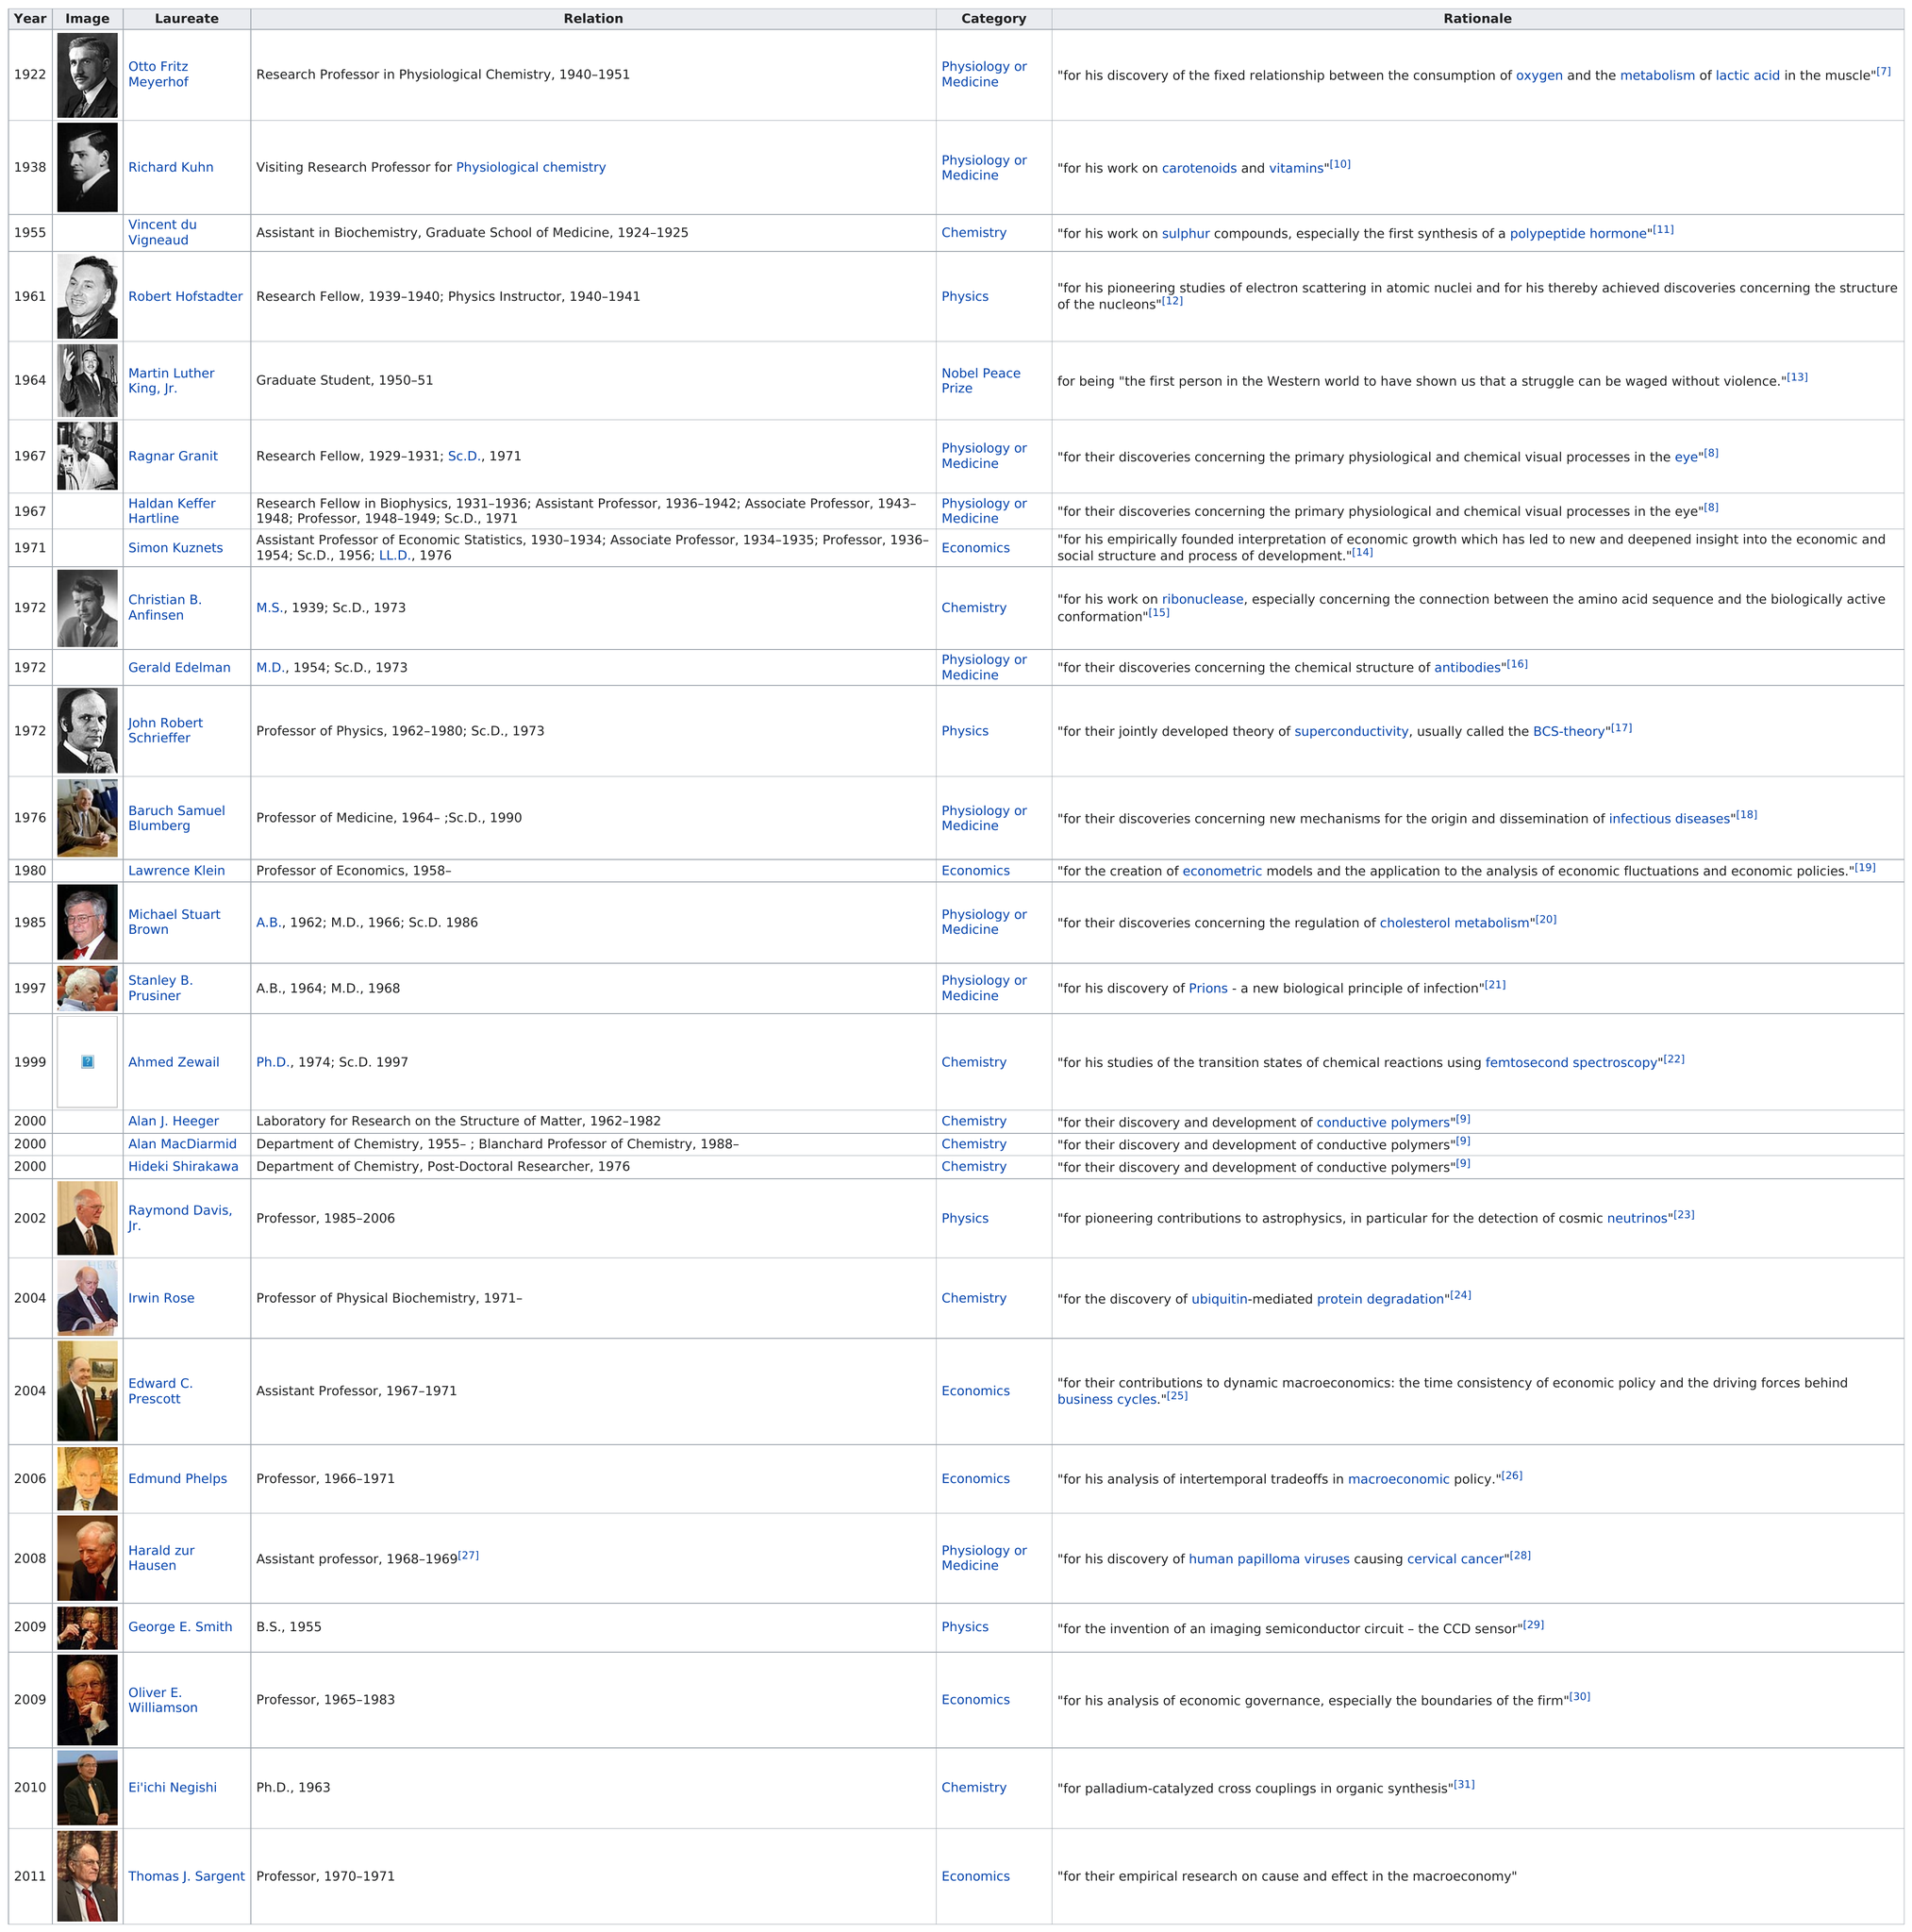Identify some key points in this picture. Who is listed below Richard Kuhn? Vincent du Vigneaud. Martin Luther King Jr. received his laureate 13 years after he completed his graduate studies. Otto Fritz Meyerhof worked as a research professor in physiological chemistry for 11 years. Otto Fritz Meyerhof was the first Nobel laureate from the University of Pennsylvania. Out of the laureates, a significant number of them received the Nobel Peace Prize, with 1 being one of them. 